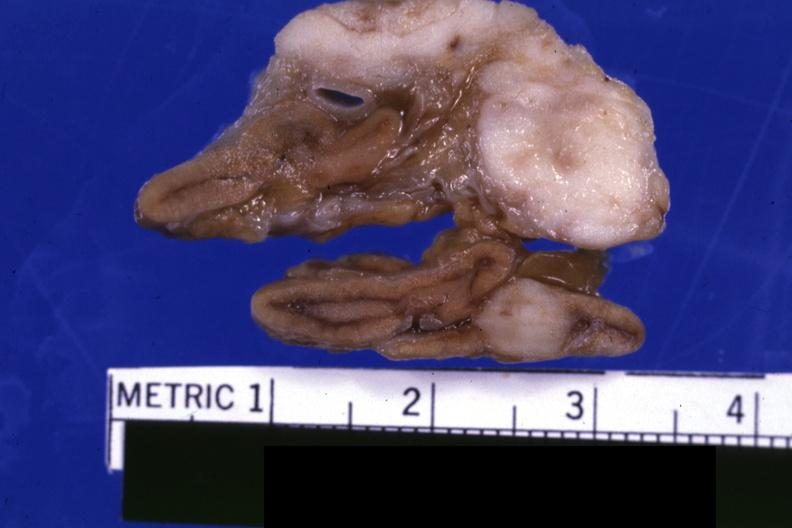s adrenal present?
Answer the question using a single word or phrase. Yes 